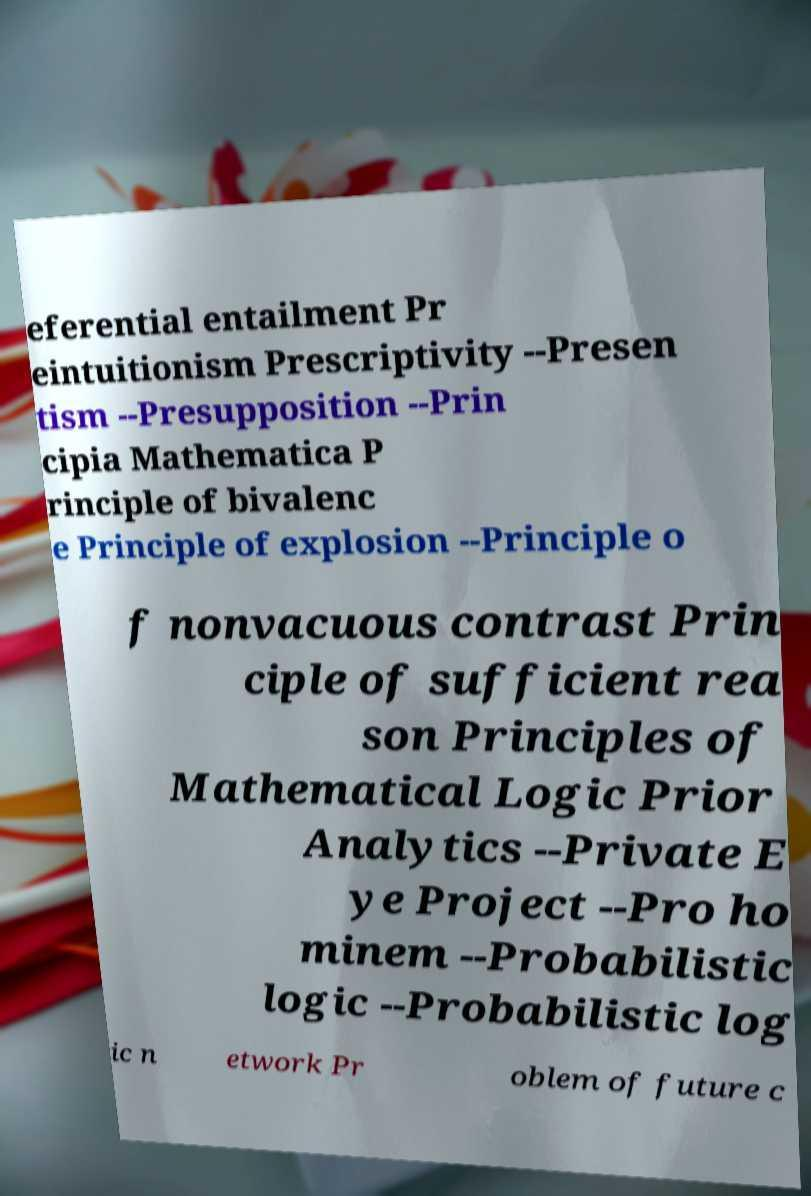What messages or text are displayed in this image? I need them in a readable, typed format. eferential entailment Pr eintuitionism Prescriptivity --Presen tism --Presupposition --Prin cipia Mathematica P rinciple of bivalenc e Principle of explosion --Principle o f nonvacuous contrast Prin ciple of sufficient rea son Principles of Mathematical Logic Prior Analytics --Private E ye Project --Pro ho minem --Probabilistic logic --Probabilistic log ic n etwork Pr oblem of future c 